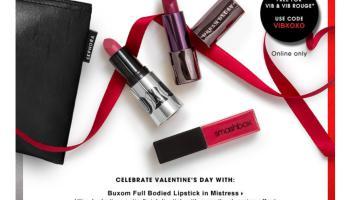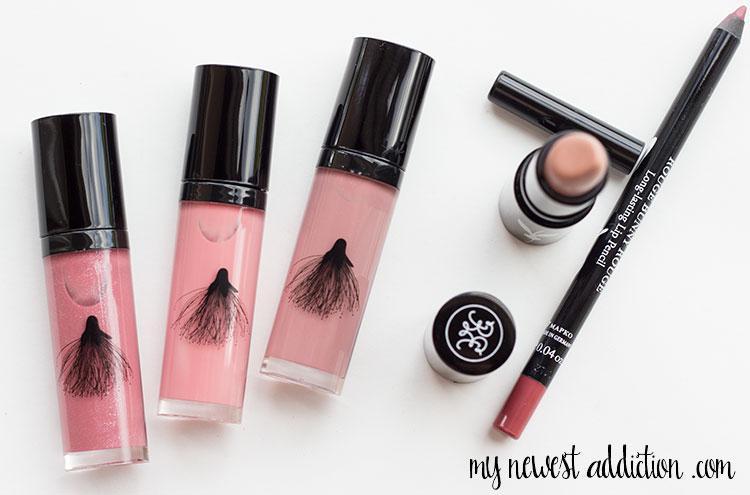The first image is the image on the left, the second image is the image on the right. Given the left and right images, does the statement "One of the images has only two makeups, and the" hold true? Answer yes or no. No. The first image is the image on the left, the second image is the image on the right. Analyze the images presented: Is the assertion "At least one of the images is of Dior lipstick colors" valid? Answer yes or no. No. 